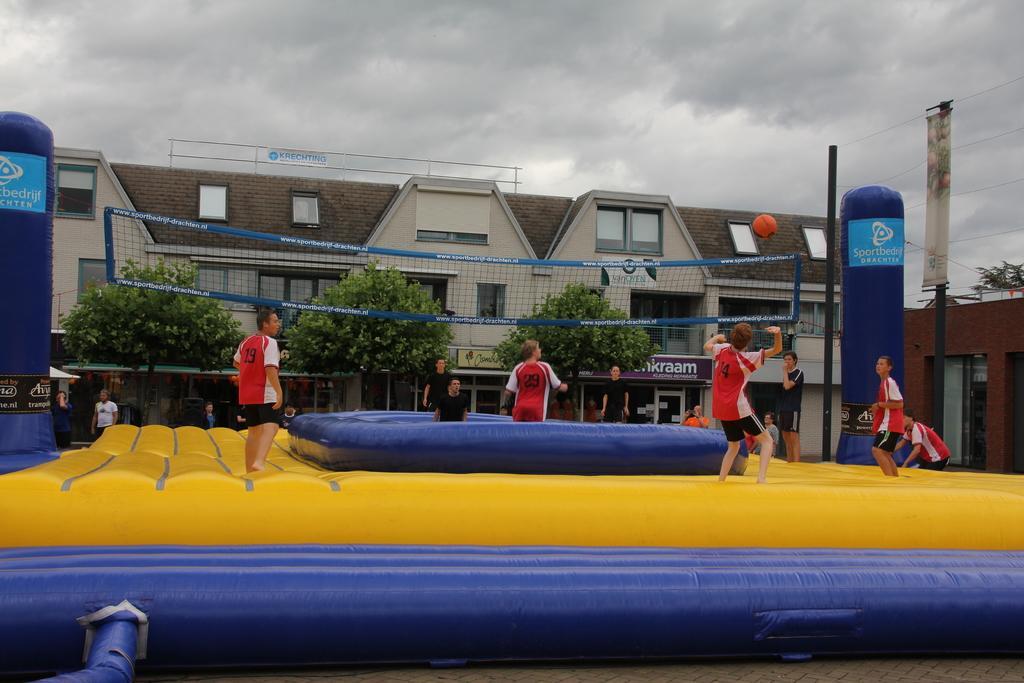In one or two sentences, can you explain what this image depicts? A person is standing trying to hit the ball, here other people are standing, this is net, there are trees and a building, this is sky. 